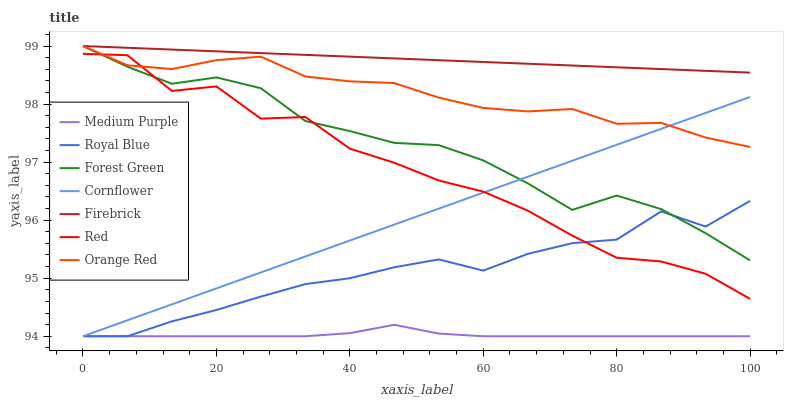Does Medium Purple have the minimum area under the curve?
Answer yes or no. Yes. Does Firebrick have the maximum area under the curve?
Answer yes or no. Yes. Does Firebrick have the minimum area under the curve?
Answer yes or no. No. Does Medium Purple have the maximum area under the curve?
Answer yes or no. No. Is Cornflower the smoothest?
Answer yes or no. Yes. Is Red the roughest?
Answer yes or no. Yes. Is Firebrick the smoothest?
Answer yes or no. No. Is Firebrick the roughest?
Answer yes or no. No. Does Cornflower have the lowest value?
Answer yes or no. Yes. Does Firebrick have the lowest value?
Answer yes or no. No. Does Orange Red have the highest value?
Answer yes or no. Yes. Does Medium Purple have the highest value?
Answer yes or no. No. Is Royal Blue less than Firebrick?
Answer yes or no. Yes. Is Firebrick greater than Medium Purple?
Answer yes or no. Yes. Does Orange Red intersect Red?
Answer yes or no. Yes. Is Orange Red less than Red?
Answer yes or no. No. Is Orange Red greater than Red?
Answer yes or no. No. Does Royal Blue intersect Firebrick?
Answer yes or no. No. 